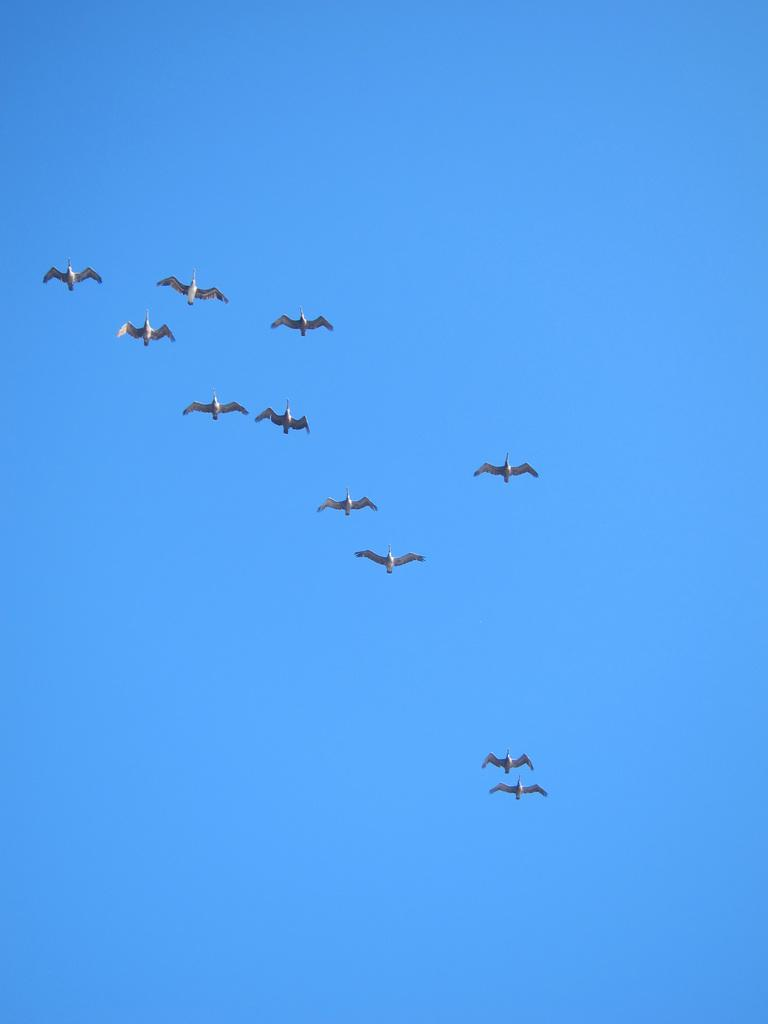What type of animals can be seen in the image? Birds can be seen in the image. What are the birds doing in the image? The birds are flying in the sky. Where is the camp located in the image? There is no camp present in the image; it features birds flying in the sky. What type of furniture can be seen in the bedroom in the image? There is no bedroom present in the image; it features birds flying in the sky. 